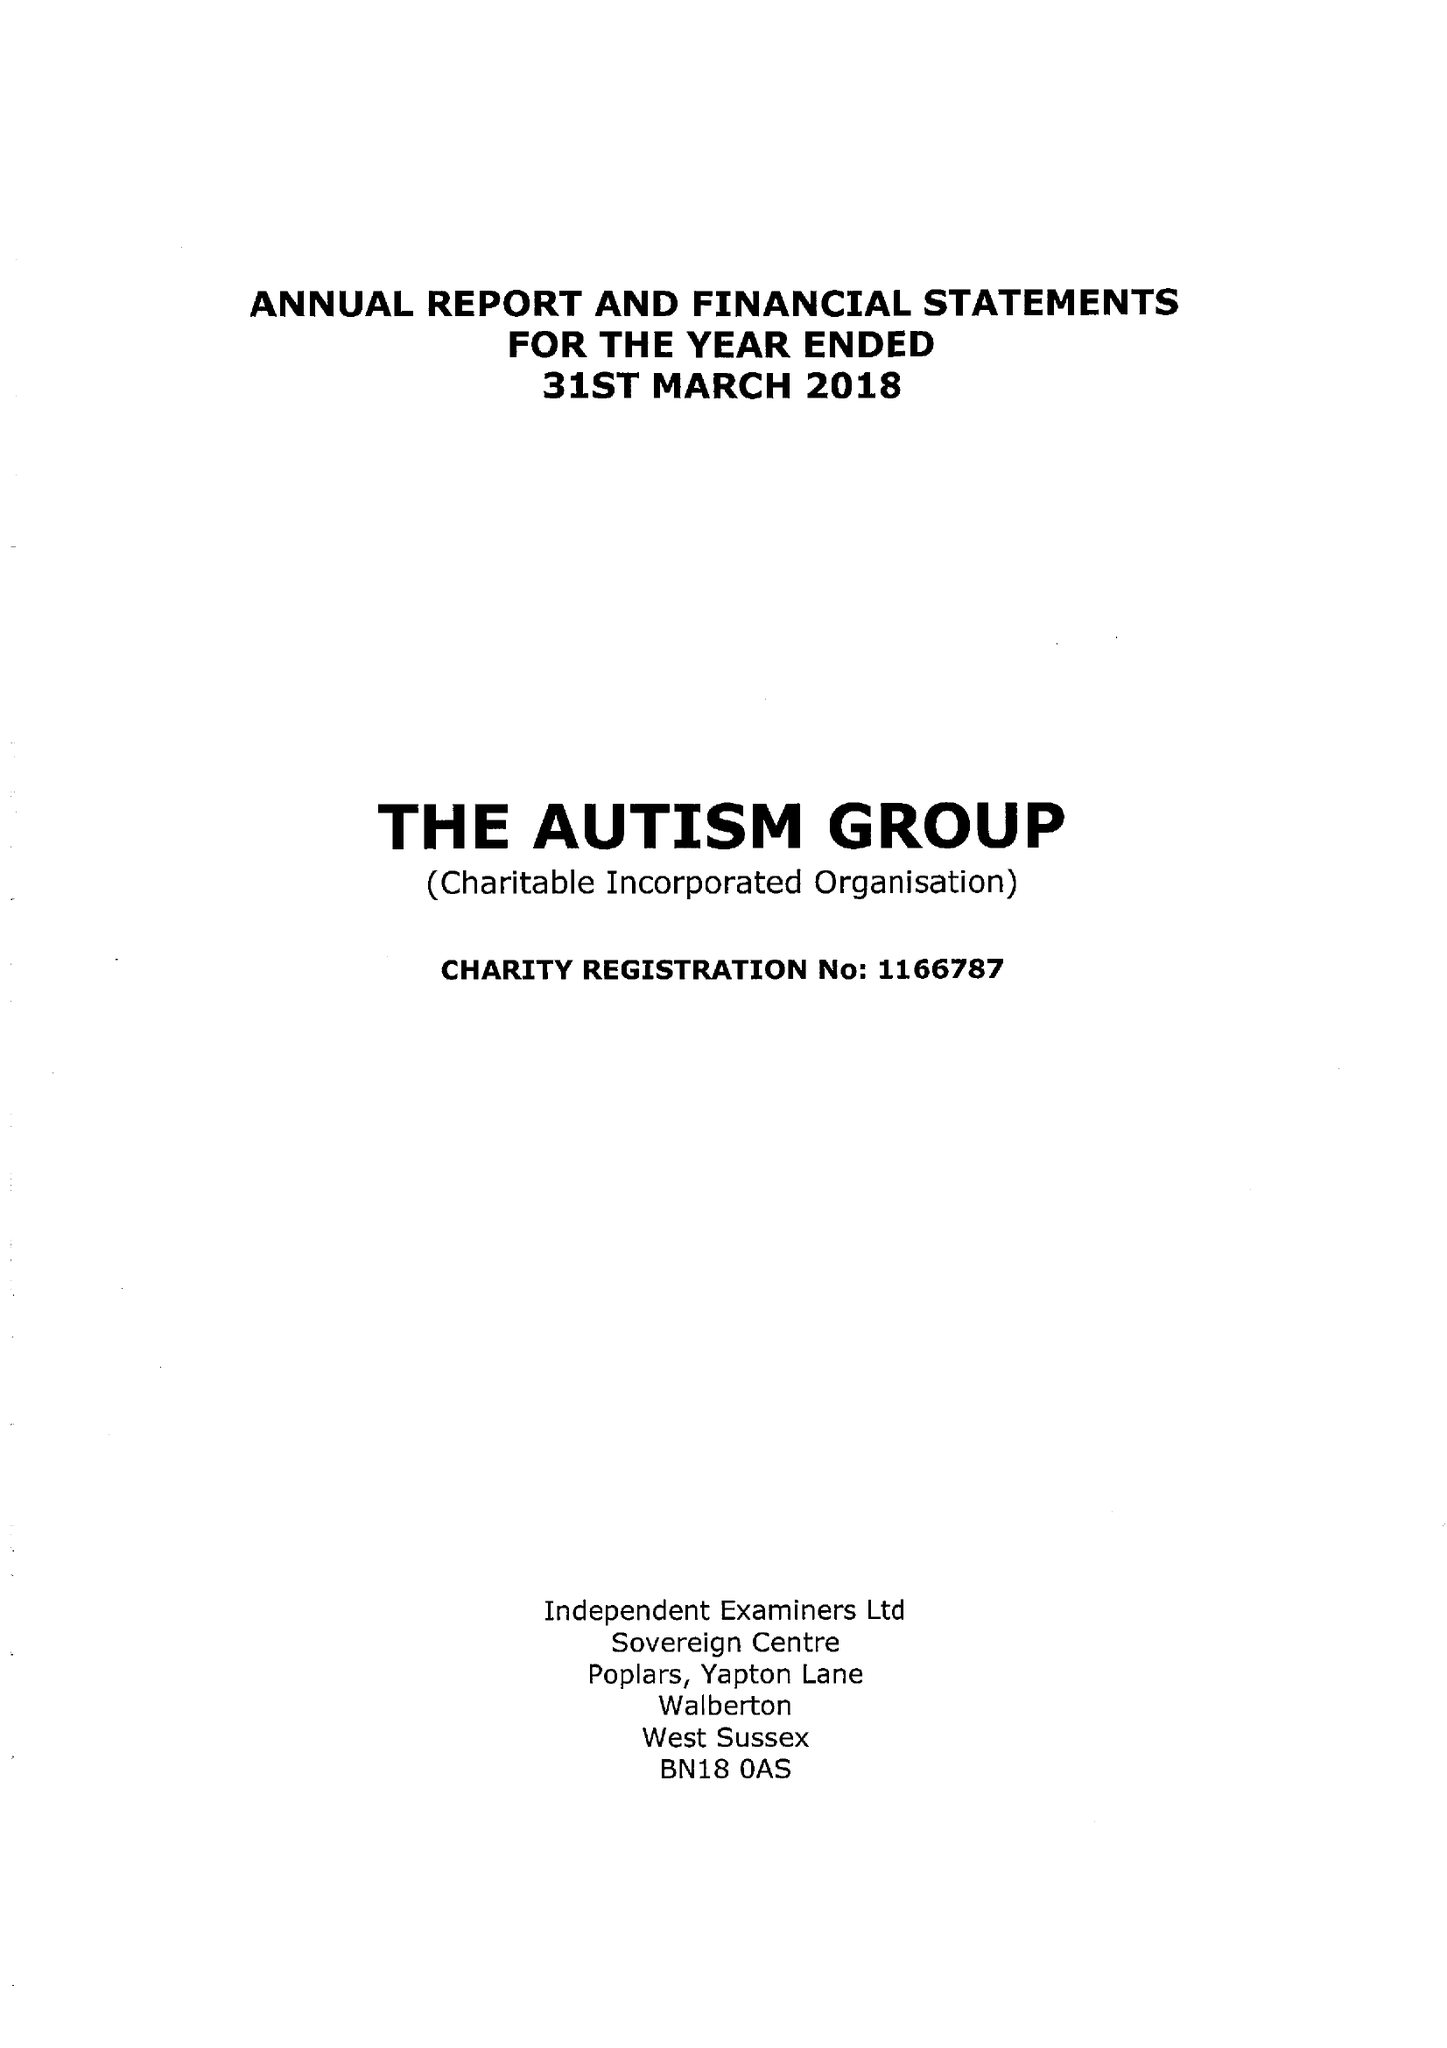What is the value for the report_date?
Answer the question using a single word or phrase. 2018-03-31 